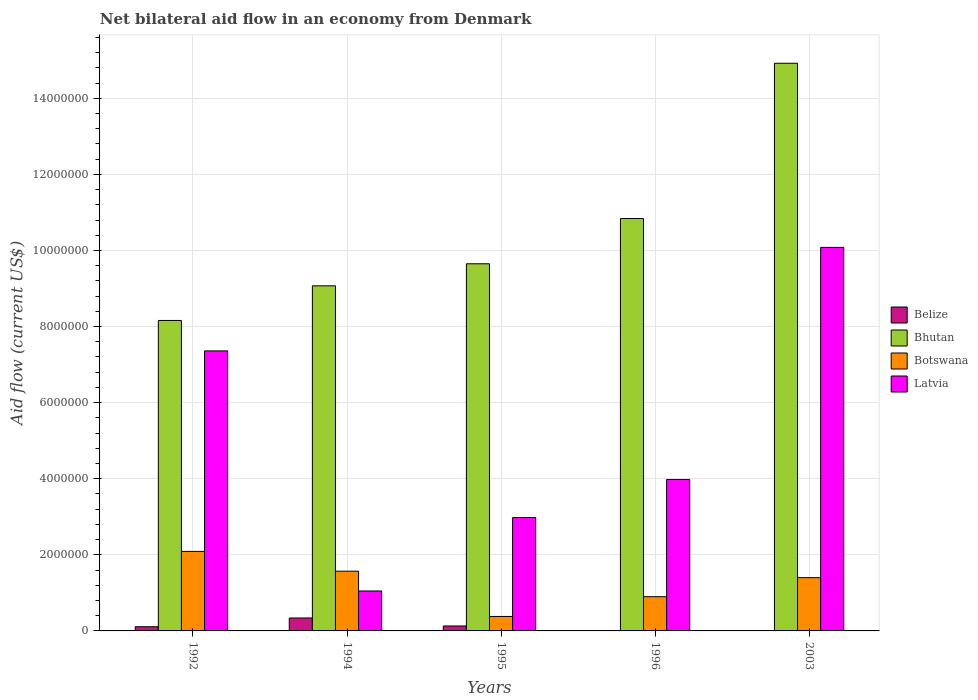How many different coloured bars are there?
Provide a short and direct response. 4. How many bars are there on the 1st tick from the left?
Your answer should be very brief. 4. Across all years, what is the maximum net bilateral aid flow in Bhutan?
Offer a terse response. 1.49e+07. Across all years, what is the minimum net bilateral aid flow in Bhutan?
Offer a terse response. 8.16e+06. In which year was the net bilateral aid flow in Latvia maximum?
Give a very brief answer. 2003. What is the total net bilateral aid flow in Botswana in the graph?
Offer a terse response. 6.34e+06. What is the difference between the net bilateral aid flow in Botswana in 1992 and the net bilateral aid flow in Bhutan in 1994?
Ensure brevity in your answer.  -6.98e+06. What is the average net bilateral aid flow in Belize per year?
Offer a very short reply. 1.16e+05. What is the ratio of the net bilateral aid flow in Botswana in 1992 to that in 1995?
Your response must be concise. 5.5. Is the net bilateral aid flow in Latvia in 1996 less than that in 2003?
Offer a terse response. Yes. Is the difference between the net bilateral aid flow in Belize in 1992 and 1994 greater than the difference between the net bilateral aid flow in Botswana in 1992 and 1994?
Ensure brevity in your answer.  No. What is the difference between the highest and the second highest net bilateral aid flow in Belize?
Your answer should be very brief. 2.10e+05. What is the difference between the highest and the lowest net bilateral aid flow in Botswana?
Keep it short and to the point. 1.71e+06. Are all the bars in the graph horizontal?
Give a very brief answer. No. How many years are there in the graph?
Offer a very short reply. 5. What is the difference between two consecutive major ticks on the Y-axis?
Provide a succinct answer. 2.00e+06. Does the graph contain any zero values?
Provide a short and direct response. Yes. Does the graph contain grids?
Your answer should be compact. Yes. How are the legend labels stacked?
Your response must be concise. Vertical. What is the title of the graph?
Make the answer very short. Net bilateral aid flow in an economy from Denmark. What is the Aid flow (current US$) of Bhutan in 1992?
Ensure brevity in your answer.  8.16e+06. What is the Aid flow (current US$) of Botswana in 1992?
Provide a short and direct response. 2.09e+06. What is the Aid flow (current US$) of Latvia in 1992?
Your answer should be compact. 7.36e+06. What is the Aid flow (current US$) in Belize in 1994?
Your answer should be compact. 3.40e+05. What is the Aid flow (current US$) of Bhutan in 1994?
Provide a short and direct response. 9.07e+06. What is the Aid flow (current US$) of Botswana in 1994?
Provide a short and direct response. 1.57e+06. What is the Aid flow (current US$) in Latvia in 1994?
Your response must be concise. 1.05e+06. What is the Aid flow (current US$) of Bhutan in 1995?
Give a very brief answer. 9.65e+06. What is the Aid flow (current US$) of Latvia in 1995?
Your answer should be very brief. 2.98e+06. What is the Aid flow (current US$) of Belize in 1996?
Provide a short and direct response. 0. What is the Aid flow (current US$) in Bhutan in 1996?
Your answer should be compact. 1.08e+07. What is the Aid flow (current US$) in Botswana in 1996?
Offer a terse response. 9.00e+05. What is the Aid flow (current US$) of Latvia in 1996?
Give a very brief answer. 3.98e+06. What is the Aid flow (current US$) in Bhutan in 2003?
Your response must be concise. 1.49e+07. What is the Aid flow (current US$) of Botswana in 2003?
Offer a terse response. 1.40e+06. What is the Aid flow (current US$) in Latvia in 2003?
Offer a terse response. 1.01e+07. Across all years, what is the maximum Aid flow (current US$) in Bhutan?
Keep it short and to the point. 1.49e+07. Across all years, what is the maximum Aid flow (current US$) of Botswana?
Ensure brevity in your answer.  2.09e+06. Across all years, what is the maximum Aid flow (current US$) in Latvia?
Ensure brevity in your answer.  1.01e+07. Across all years, what is the minimum Aid flow (current US$) in Belize?
Give a very brief answer. 0. Across all years, what is the minimum Aid flow (current US$) of Bhutan?
Keep it short and to the point. 8.16e+06. Across all years, what is the minimum Aid flow (current US$) in Botswana?
Provide a succinct answer. 3.80e+05. Across all years, what is the minimum Aid flow (current US$) in Latvia?
Offer a very short reply. 1.05e+06. What is the total Aid flow (current US$) of Belize in the graph?
Give a very brief answer. 5.80e+05. What is the total Aid flow (current US$) of Bhutan in the graph?
Provide a succinct answer. 5.26e+07. What is the total Aid flow (current US$) in Botswana in the graph?
Ensure brevity in your answer.  6.34e+06. What is the total Aid flow (current US$) of Latvia in the graph?
Your answer should be very brief. 2.54e+07. What is the difference between the Aid flow (current US$) in Belize in 1992 and that in 1994?
Make the answer very short. -2.30e+05. What is the difference between the Aid flow (current US$) in Bhutan in 1992 and that in 1994?
Provide a short and direct response. -9.10e+05. What is the difference between the Aid flow (current US$) of Botswana in 1992 and that in 1994?
Your response must be concise. 5.20e+05. What is the difference between the Aid flow (current US$) in Latvia in 1992 and that in 1994?
Your answer should be compact. 6.31e+06. What is the difference between the Aid flow (current US$) of Bhutan in 1992 and that in 1995?
Ensure brevity in your answer.  -1.49e+06. What is the difference between the Aid flow (current US$) of Botswana in 1992 and that in 1995?
Ensure brevity in your answer.  1.71e+06. What is the difference between the Aid flow (current US$) in Latvia in 1992 and that in 1995?
Give a very brief answer. 4.38e+06. What is the difference between the Aid flow (current US$) of Bhutan in 1992 and that in 1996?
Give a very brief answer. -2.68e+06. What is the difference between the Aid flow (current US$) of Botswana in 1992 and that in 1996?
Keep it short and to the point. 1.19e+06. What is the difference between the Aid flow (current US$) of Latvia in 1992 and that in 1996?
Offer a very short reply. 3.38e+06. What is the difference between the Aid flow (current US$) of Bhutan in 1992 and that in 2003?
Your answer should be very brief. -6.76e+06. What is the difference between the Aid flow (current US$) in Botswana in 1992 and that in 2003?
Ensure brevity in your answer.  6.90e+05. What is the difference between the Aid flow (current US$) in Latvia in 1992 and that in 2003?
Your answer should be compact. -2.72e+06. What is the difference between the Aid flow (current US$) in Belize in 1994 and that in 1995?
Offer a very short reply. 2.10e+05. What is the difference between the Aid flow (current US$) of Bhutan in 1994 and that in 1995?
Make the answer very short. -5.80e+05. What is the difference between the Aid flow (current US$) of Botswana in 1994 and that in 1995?
Your answer should be very brief. 1.19e+06. What is the difference between the Aid flow (current US$) of Latvia in 1994 and that in 1995?
Your response must be concise. -1.93e+06. What is the difference between the Aid flow (current US$) of Bhutan in 1994 and that in 1996?
Your response must be concise. -1.77e+06. What is the difference between the Aid flow (current US$) in Botswana in 1994 and that in 1996?
Your answer should be compact. 6.70e+05. What is the difference between the Aid flow (current US$) of Latvia in 1994 and that in 1996?
Keep it short and to the point. -2.93e+06. What is the difference between the Aid flow (current US$) in Bhutan in 1994 and that in 2003?
Make the answer very short. -5.85e+06. What is the difference between the Aid flow (current US$) in Latvia in 1994 and that in 2003?
Provide a succinct answer. -9.03e+06. What is the difference between the Aid flow (current US$) in Bhutan in 1995 and that in 1996?
Offer a terse response. -1.19e+06. What is the difference between the Aid flow (current US$) of Botswana in 1995 and that in 1996?
Your answer should be very brief. -5.20e+05. What is the difference between the Aid flow (current US$) of Latvia in 1995 and that in 1996?
Your answer should be very brief. -1.00e+06. What is the difference between the Aid flow (current US$) in Bhutan in 1995 and that in 2003?
Your answer should be very brief. -5.27e+06. What is the difference between the Aid flow (current US$) of Botswana in 1995 and that in 2003?
Keep it short and to the point. -1.02e+06. What is the difference between the Aid flow (current US$) of Latvia in 1995 and that in 2003?
Give a very brief answer. -7.10e+06. What is the difference between the Aid flow (current US$) of Bhutan in 1996 and that in 2003?
Offer a terse response. -4.08e+06. What is the difference between the Aid flow (current US$) in Botswana in 1996 and that in 2003?
Provide a succinct answer. -5.00e+05. What is the difference between the Aid flow (current US$) of Latvia in 1996 and that in 2003?
Make the answer very short. -6.10e+06. What is the difference between the Aid flow (current US$) of Belize in 1992 and the Aid flow (current US$) of Bhutan in 1994?
Your answer should be compact. -8.96e+06. What is the difference between the Aid flow (current US$) of Belize in 1992 and the Aid flow (current US$) of Botswana in 1994?
Keep it short and to the point. -1.46e+06. What is the difference between the Aid flow (current US$) of Belize in 1992 and the Aid flow (current US$) of Latvia in 1994?
Your response must be concise. -9.40e+05. What is the difference between the Aid flow (current US$) in Bhutan in 1992 and the Aid flow (current US$) in Botswana in 1994?
Provide a succinct answer. 6.59e+06. What is the difference between the Aid flow (current US$) in Bhutan in 1992 and the Aid flow (current US$) in Latvia in 1994?
Your response must be concise. 7.11e+06. What is the difference between the Aid flow (current US$) of Botswana in 1992 and the Aid flow (current US$) of Latvia in 1994?
Ensure brevity in your answer.  1.04e+06. What is the difference between the Aid flow (current US$) of Belize in 1992 and the Aid flow (current US$) of Bhutan in 1995?
Your answer should be compact. -9.54e+06. What is the difference between the Aid flow (current US$) of Belize in 1992 and the Aid flow (current US$) of Latvia in 1995?
Provide a succinct answer. -2.87e+06. What is the difference between the Aid flow (current US$) of Bhutan in 1992 and the Aid flow (current US$) of Botswana in 1995?
Keep it short and to the point. 7.78e+06. What is the difference between the Aid flow (current US$) in Bhutan in 1992 and the Aid flow (current US$) in Latvia in 1995?
Give a very brief answer. 5.18e+06. What is the difference between the Aid flow (current US$) of Botswana in 1992 and the Aid flow (current US$) of Latvia in 1995?
Give a very brief answer. -8.90e+05. What is the difference between the Aid flow (current US$) in Belize in 1992 and the Aid flow (current US$) in Bhutan in 1996?
Your answer should be very brief. -1.07e+07. What is the difference between the Aid flow (current US$) of Belize in 1992 and the Aid flow (current US$) of Botswana in 1996?
Make the answer very short. -7.90e+05. What is the difference between the Aid flow (current US$) in Belize in 1992 and the Aid flow (current US$) in Latvia in 1996?
Give a very brief answer. -3.87e+06. What is the difference between the Aid flow (current US$) in Bhutan in 1992 and the Aid flow (current US$) in Botswana in 1996?
Provide a short and direct response. 7.26e+06. What is the difference between the Aid flow (current US$) of Bhutan in 1992 and the Aid flow (current US$) of Latvia in 1996?
Make the answer very short. 4.18e+06. What is the difference between the Aid flow (current US$) of Botswana in 1992 and the Aid flow (current US$) of Latvia in 1996?
Provide a succinct answer. -1.89e+06. What is the difference between the Aid flow (current US$) of Belize in 1992 and the Aid flow (current US$) of Bhutan in 2003?
Keep it short and to the point. -1.48e+07. What is the difference between the Aid flow (current US$) in Belize in 1992 and the Aid flow (current US$) in Botswana in 2003?
Provide a succinct answer. -1.29e+06. What is the difference between the Aid flow (current US$) of Belize in 1992 and the Aid flow (current US$) of Latvia in 2003?
Make the answer very short. -9.97e+06. What is the difference between the Aid flow (current US$) of Bhutan in 1992 and the Aid flow (current US$) of Botswana in 2003?
Make the answer very short. 6.76e+06. What is the difference between the Aid flow (current US$) of Bhutan in 1992 and the Aid flow (current US$) of Latvia in 2003?
Your answer should be very brief. -1.92e+06. What is the difference between the Aid flow (current US$) in Botswana in 1992 and the Aid flow (current US$) in Latvia in 2003?
Offer a very short reply. -7.99e+06. What is the difference between the Aid flow (current US$) in Belize in 1994 and the Aid flow (current US$) in Bhutan in 1995?
Make the answer very short. -9.31e+06. What is the difference between the Aid flow (current US$) of Belize in 1994 and the Aid flow (current US$) of Botswana in 1995?
Keep it short and to the point. -4.00e+04. What is the difference between the Aid flow (current US$) in Belize in 1994 and the Aid flow (current US$) in Latvia in 1995?
Your answer should be very brief. -2.64e+06. What is the difference between the Aid flow (current US$) in Bhutan in 1994 and the Aid flow (current US$) in Botswana in 1995?
Offer a terse response. 8.69e+06. What is the difference between the Aid flow (current US$) of Bhutan in 1994 and the Aid flow (current US$) of Latvia in 1995?
Your response must be concise. 6.09e+06. What is the difference between the Aid flow (current US$) in Botswana in 1994 and the Aid flow (current US$) in Latvia in 1995?
Give a very brief answer. -1.41e+06. What is the difference between the Aid flow (current US$) of Belize in 1994 and the Aid flow (current US$) of Bhutan in 1996?
Offer a terse response. -1.05e+07. What is the difference between the Aid flow (current US$) of Belize in 1994 and the Aid flow (current US$) of Botswana in 1996?
Your response must be concise. -5.60e+05. What is the difference between the Aid flow (current US$) of Belize in 1994 and the Aid flow (current US$) of Latvia in 1996?
Make the answer very short. -3.64e+06. What is the difference between the Aid flow (current US$) in Bhutan in 1994 and the Aid flow (current US$) in Botswana in 1996?
Your answer should be compact. 8.17e+06. What is the difference between the Aid flow (current US$) of Bhutan in 1994 and the Aid flow (current US$) of Latvia in 1996?
Ensure brevity in your answer.  5.09e+06. What is the difference between the Aid flow (current US$) of Botswana in 1994 and the Aid flow (current US$) of Latvia in 1996?
Ensure brevity in your answer.  -2.41e+06. What is the difference between the Aid flow (current US$) in Belize in 1994 and the Aid flow (current US$) in Bhutan in 2003?
Provide a short and direct response. -1.46e+07. What is the difference between the Aid flow (current US$) in Belize in 1994 and the Aid flow (current US$) in Botswana in 2003?
Make the answer very short. -1.06e+06. What is the difference between the Aid flow (current US$) in Belize in 1994 and the Aid flow (current US$) in Latvia in 2003?
Offer a terse response. -9.74e+06. What is the difference between the Aid flow (current US$) of Bhutan in 1994 and the Aid flow (current US$) of Botswana in 2003?
Offer a terse response. 7.67e+06. What is the difference between the Aid flow (current US$) of Bhutan in 1994 and the Aid flow (current US$) of Latvia in 2003?
Your answer should be compact. -1.01e+06. What is the difference between the Aid flow (current US$) of Botswana in 1994 and the Aid flow (current US$) of Latvia in 2003?
Provide a succinct answer. -8.51e+06. What is the difference between the Aid flow (current US$) in Belize in 1995 and the Aid flow (current US$) in Bhutan in 1996?
Provide a short and direct response. -1.07e+07. What is the difference between the Aid flow (current US$) of Belize in 1995 and the Aid flow (current US$) of Botswana in 1996?
Your response must be concise. -7.70e+05. What is the difference between the Aid flow (current US$) of Belize in 1995 and the Aid flow (current US$) of Latvia in 1996?
Your answer should be very brief. -3.85e+06. What is the difference between the Aid flow (current US$) in Bhutan in 1995 and the Aid flow (current US$) in Botswana in 1996?
Ensure brevity in your answer.  8.75e+06. What is the difference between the Aid flow (current US$) in Bhutan in 1995 and the Aid flow (current US$) in Latvia in 1996?
Offer a terse response. 5.67e+06. What is the difference between the Aid flow (current US$) in Botswana in 1995 and the Aid flow (current US$) in Latvia in 1996?
Offer a terse response. -3.60e+06. What is the difference between the Aid flow (current US$) of Belize in 1995 and the Aid flow (current US$) of Bhutan in 2003?
Offer a very short reply. -1.48e+07. What is the difference between the Aid flow (current US$) of Belize in 1995 and the Aid flow (current US$) of Botswana in 2003?
Offer a terse response. -1.27e+06. What is the difference between the Aid flow (current US$) in Belize in 1995 and the Aid flow (current US$) in Latvia in 2003?
Offer a very short reply. -9.95e+06. What is the difference between the Aid flow (current US$) of Bhutan in 1995 and the Aid flow (current US$) of Botswana in 2003?
Your answer should be very brief. 8.25e+06. What is the difference between the Aid flow (current US$) in Bhutan in 1995 and the Aid flow (current US$) in Latvia in 2003?
Your answer should be very brief. -4.30e+05. What is the difference between the Aid flow (current US$) of Botswana in 1995 and the Aid flow (current US$) of Latvia in 2003?
Ensure brevity in your answer.  -9.70e+06. What is the difference between the Aid flow (current US$) of Bhutan in 1996 and the Aid flow (current US$) of Botswana in 2003?
Offer a very short reply. 9.44e+06. What is the difference between the Aid flow (current US$) in Bhutan in 1996 and the Aid flow (current US$) in Latvia in 2003?
Your response must be concise. 7.60e+05. What is the difference between the Aid flow (current US$) in Botswana in 1996 and the Aid flow (current US$) in Latvia in 2003?
Your answer should be very brief. -9.18e+06. What is the average Aid flow (current US$) of Belize per year?
Give a very brief answer. 1.16e+05. What is the average Aid flow (current US$) in Bhutan per year?
Provide a succinct answer. 1.05e+07. What is the average Aid flow (current US$) of Botswana per year?
Your answer should be very brief. 1.27e+06. What is the average Aid flow (current US$) of Latvia per year?
Offer a very short reply. 5.09e+06. In the year 1992, what is the difference between the Aid flow (current US$) in Belize and Aid flow (current US$) in Bhutan?
Provide a succinct answer. -8.05e+06. In the year 1992, what is the difference between the Aid flow (current US$) in Belize and Aid flow (current US$) in Botswana?
Make the answer very short. -1.98e+06. In the year 1992, what is the difference between the Aid flow (current US$) in Belize and Aid flow (current US$) in Latvia?
Your response must be concise. -7.25e+06. In the year 1992, what is the difference between the Aid flow (current US$) in Bhutan and Aid flow (current US$) in Botswana?
Your answer should be compact. 6.07e+06. In the year 1992, what is the difference between the Aid flow (current US$) in Botswana and Aid flow (current US$) in Latvia?
Ensure brevity in your answer.  -5.27e+06. In the year 1994, what is the difference between the Aid flow (current US$) of Belize and Aid flow (current US$) of Bhutan?
Keep it short and to the point. -8.73e+06. In the year 1994, what is the difference between the Aid flow (current US$) in Belize and Aid flow (current US$) in Botswana?
Offer a terse response. -1.23e+06. In the year 1994, what is the difference between the Aid flow (current US$) of Belize and Aid flow (current US$) of Latvia?
Provide a short and direct response. -7.10e+05. In the year 1994, what is the difference between the Aid flow (current US$) of Bhutan and Aid flow (current US$) of Botswana?
Provide a short and direct response. 7.50e+06. In the year 1994, what is the difference between the Aid flow (current US$) in Bhutan and Aid flow (current US$) in Latvia?
Provide a short and direct response. 8.02e+06. In the year 1994, what is the difference between the Aid flow (current US$) in Botswana and Aid flow (current US$) in Latvia?
Your response must be concise. 5.20e+05. In the year 1995, what is the difference between the Aid flow (current US$) of Belize and Aid flow (current US$) of Bhutan?
Make the answer very short. -9.52e+06. In the year 1995, what is the difference between the Aid flow (current US$) of Belize and Aid flow (current US$) of Latvia?
Your answer should be very brief. -2.85e+06. In the year 1995, what is the difference between the Aid flow (current US$) of Bhutan and Aid flow (current US$) of Botswana?
Provide a short and direct response. 9.27e+06. In the year 1995, what is the difference between the Aid flow (current US$) in Bhutan and Aid flow (current US$) in Latvia?
Ensure brevity in your answer.  6.67e+06. In the year 1995, what is the difference between the Aid flow (current US$) in Botswana and Aid flow (current US$) in Latvia?
Your answer should be very brief. -2.60e+06. In the year 1996, what is the difference between the Aid flow (current US$) in Bhutan and Aid flow (current US$) in Botswana?
Ensure brevity in your answer.  9.94e+06. In the year 1996, what is the difference between the Aid flow (current US$) in Bhutan and Aid flow (current US$) in Latvia?
Offer a very short reply. 6.86e+06. In the year 1996, what is the difference between the Aid flow (current US$) of Botswana and Aid flow (current US$) of Latvia?
Your response must be concise. -3.08e+06. In the year 2003, what is the difference between the Aid flow (current US$) of Bhutan and Aid flow (current US$) of Botswana?
Keep it short and to the point. 1.35e+07. In the year 2003, what is the difference between the Aid flow (current US$) of Bhutan and Aid flow (current US$) of Latvia?
Make the answer very short. 4.84e+06. In the year 2003, what is the difference between the Aid flow (current US$) in Botswana and Aid flow (current US$) in Latvia?
Provide a short and direct response. -8.68e+06. What is the ratio of the Aid flow (current US$) in Belize in 1992 to that in 1994?
Ensure brevity in your answer.  0.32. What is the ratio of the Aid flow (current US$) of Bhutan in 1992 to that in 1994?
Provide a short and direct response. 0.9. What is the ratio of the Aid flow (current US$) of Botswana in 1992 to that in 1994?
Your answer should be compact. 1.33. What is the ratio of the Aid flow (current US$) in Latvia in 1992 to that in 1994?
Provide a short and direct response. 7.01. What is the ratio of the Aid flow (current US$) of Belize in 1992 to that in 1995?
Your response must be concise. 0.85. What is the ratio of the Aid flow (current US$) in Bhutan in 1992 to that in 1995?
Offer a very short reply. 0.85. What is the ratio of the Aid flow (current US$) of Botswana in 1992 to that in 1995?
Make the answer very short. 5.5. What is the ratio of the Aid flow (current US$) of Latvia in 1992 to that in 1995?
Keep it short and to the point. 2.47. What is the ratio of the Aid flow (current US$) in Bhutan in 1992 to that in 1996?
Provide a succinct answer. 0.75. What is the ratio of the Aid flow (current US$) in Botswana in 1992 to that in 1996?
Ensure brevity in your answer.  2.32. What is the ratio of the Aid flow (current US$) in Latvia in 1992 to that in 1996?
Provide a short and direct response. 1.85. What is the ratio of the Aid flow (current US$) of Bhutan in 1992 to that in 2003?
Your answer should be very brief. 0.55. What is the ratio of the Aid flow (current US$) of Botswana in 1992 to that in 2003?
Your response must be concise. 1.49. What is the ratio of the Aid flow (current US$) in Latvia in 1992 to that in 2003?
Provide a short and direct response. 0.73. What is the ratio of the Aid flow (current US$) of Belize in 1994 to that in 1995?
Make the answer very short. 2.62. What is the ratio of the Aid flow (current US$) in Bhutan in 1994 to that in 1995?
Ensure brevity in your answer.  0.94. What is the ratio of the Aid flow (current US$) of Botswana in 1994 to that in 1995?
Keep it short and to the point. 4.13. What is the ratio of the Aid flow (current US$) in Latvia in 1994 to that in 1995?
Ensure brevity in your answer.  0.35. What is the ratio of the Aid flow (current US$) in Bhutan in 1994 to that in 1996?
Your response must be concise. 0.84. What is the ratio of the Aid flow (current US$) of Botswana in 1994 to that in 1996?
Offer a terse response. 1.74. What is the ratio of the Aid flow (current US$) of Latvia in 1994 to that in 1996?
Offer a very short reply. 0.26. What is the ratio of the Aid flow (current US$) in Bhutan in 1994 to that in 2003?
Make the answer very short. 0.61. What is the ratio of the Aid flow (current US$) in Botswana in 1994 to that in 2003?
Make the answer very short. 1.12. What is the ratio of the Aid flow (current US$) in Latvia in 1994 to that in 2003?
Offer a terse response. 0.1. What is the ratio of the Aid flow (current US$) in Bhutan in 1995 to that in 1996?
Ensure brevity in your answer.  0.89. What is the ratio of the Aid flow (current US$) of Botswana in 1995 to that in 1996?
Give a very brief answer. 0.42. What is the ratio of the Aid flow (current US$) of Latvia in 1995 to that in 1996?
Offer a terse response. 0.75. What is the ratio of the Aid flow (current US$) of Bhutan in 1995 to that in 2003?
Provide a short and direct response. 0.65. What is the ratio of the Aid flow (current US$) in Botswana in 1995 to that in 2003?
Provide a short and direct response. 0.27. What is the ratio of the Aid flow (current US$) in Latvia in 1995 to that in 2003?
Your answer should be very brief. 0.3. What is the ratio of the Aid flow (current US$) in Bhutan in 1996 to that in 2003?
Keep it short and to the point. 0.73. What is the ratio of the Aid flow (current US$) of Botswana in 1996 to that in 2003?
Your answer should be very brief. 0.64. What is the ratio of the Aid flow (current US$) of Latvia in 1996 to that in 2003?
Make the answer very short. 0.39. What is the difference between the highest and the second highest Aid flow (current US$) of Bhutan?
Offer a very short reply. 4.08e+06. What is the difference between the highest and the second highest Aid flow (current US$) of Botswana?
Keep it short and to the point. 5.20e+05. What is the difference between the highest and the second highest Aid flow (current US$) of Latvia?
Ensure brevity in your answer.  2.72e+06. What is the difference between the highest and the lowest Aid flow (current US$) of Bhutan?
Keep it short and to the point. 6.76e+06. What is the difference between the highest and the lowest Aid flow (current US$) in Botswana?
Your answer should be very brief. 1.71e+06. What is the difference between the highest and the lowest Aid flow (current US$) of Latvia?
Provide a succinct answer. 9.03e+06. 